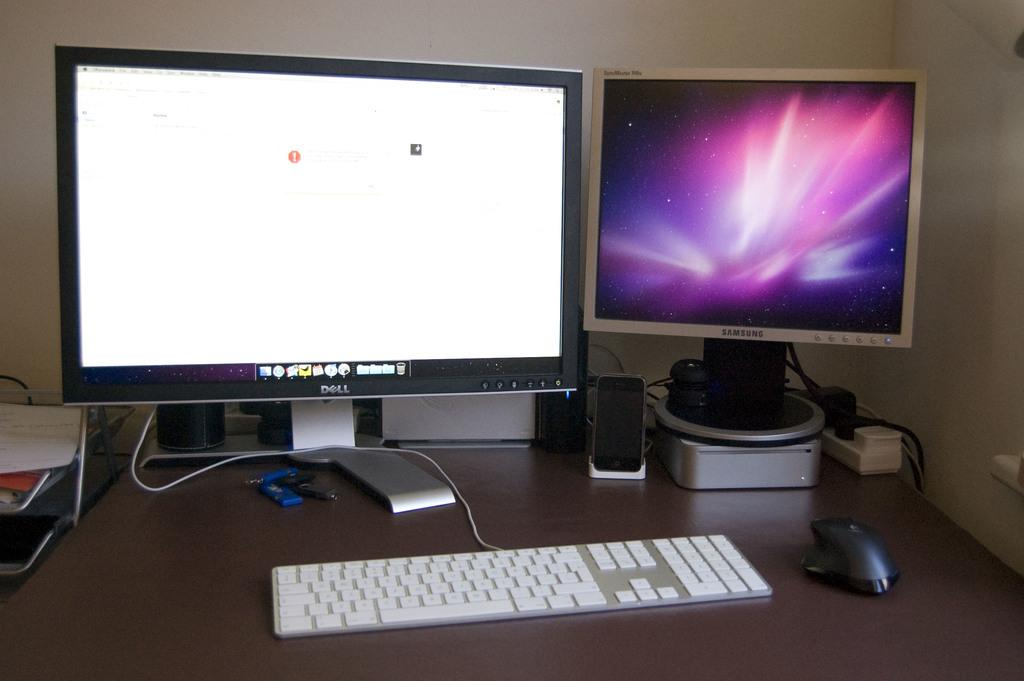How many monitors are visible in the image? There are two monitors in the image. What other electronic devices can be seen in the image? Speaker boxes are visible in the image. What input device is present in the image? There is a mouse in the image. What is used for typing in the image? There is a keyboard in the image. What small accessory is present in the image? There is a keychain in the image. Where are these objects placed? These objects are placed on a table. What can be seen in the background of the image? There is a wall visible in the background of the image. How many children are playing with the keychain in the image? There are no children present in the image, and therefore no such activity can be observed. Can you tell me the name of the friend who is using the keyboard in the image? There is no friend present in the image; only the keyboard and other objects are visible. 